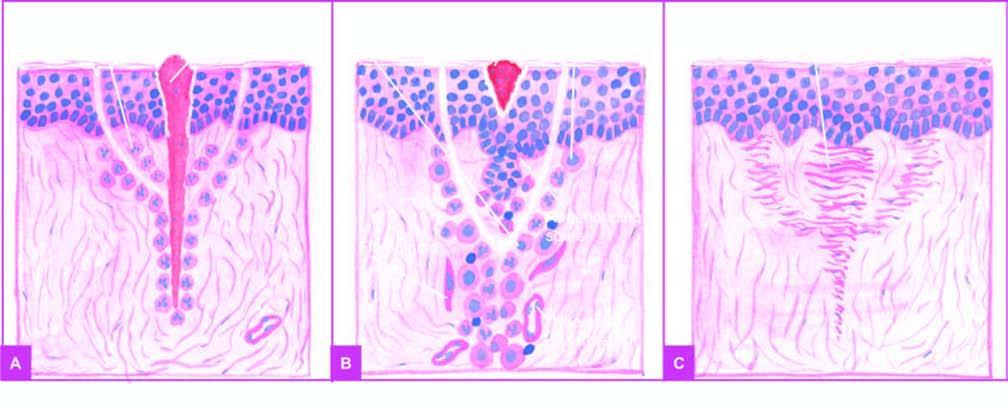does the affected part begin from below?
Answer the question using a single word or phrase. No 